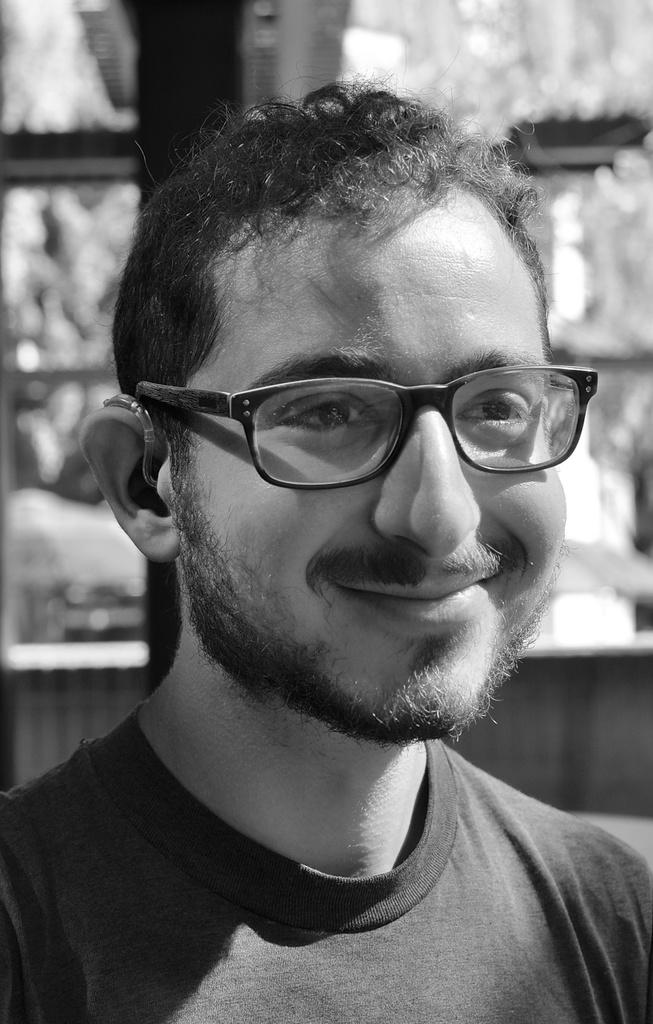What is the color scheme of the image? The image is black and white. Can you describe the main subject in the image? There is a man in the image. What can be observed about the background of the image? The background of the image is blurred. How many friends does the man have in the image? The image does not show any friends with the man, so it cannot be determined how many friends he has. 